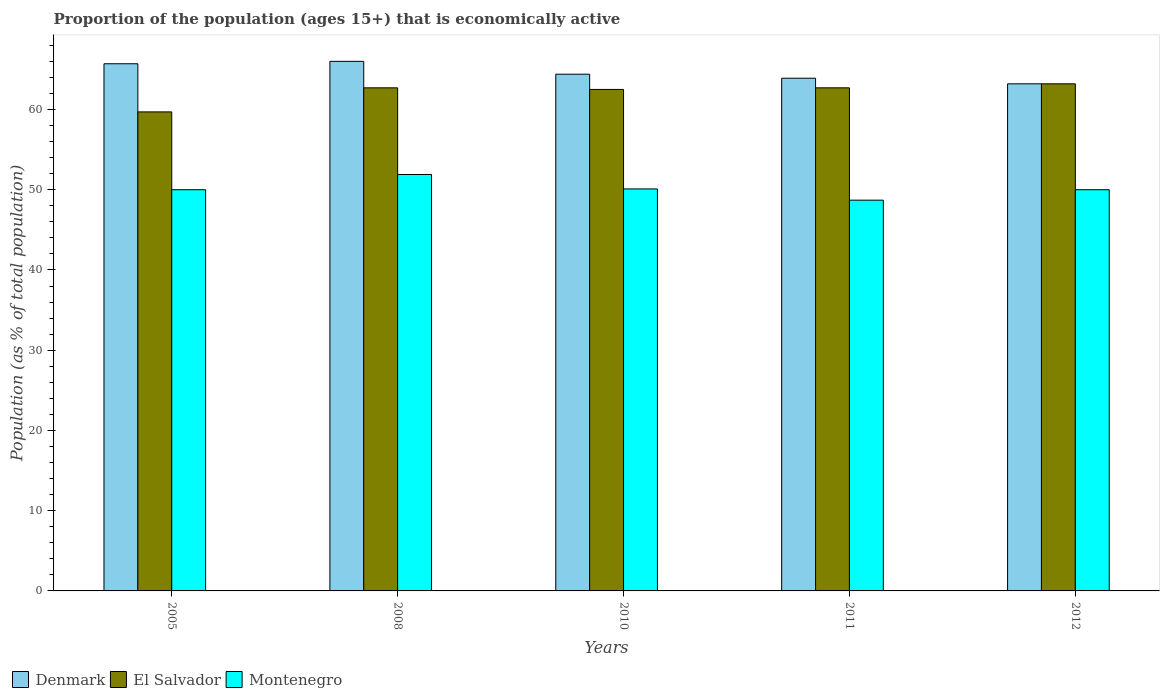Are the number of bars on each tick of the X-axis equal?
Your answer should be compact. Yes. In how many cases, is the number of bars for a given year not equal to the number of legend labels?
Give a very brief answer. 0. Across all years, what is the maximum proportion of the population that is economically active in Montenegro?
Provide a short and direct response. 51.9. Across all years, what is the minimum proportion of the population that is economically active in El Salvador?
Keep it short and to the point. 59.7. In which year was the proportion of the population that is economically active in El Salvador maximum?
Provide a short and direct response. 2012. In which year was the proportion of the population that is economically active in Montenegro minimum?
Your answer should be compact. 2011. What is the total proportion of the population that is economically active in Montenegro in the graph?
Your answer should be very brief. 250.7. What is the difference between the proportion of the population that is economically active in Denmark in 2008 and that in 2011?
Give a very brief answer. 2.1. What is the difference between the proportion of the population that is economically active in Montenegro in 2005 and the proportion of the population that is economically active in Denmark in 2012?
Offer a terse response. -13.2. What is the average proportion of the population that is economically active in Montenegro per year?
Make the answer very short. 50.14. In the year 2011, what is the difference between the proportion of the population that is economically active in Denmark and proportion of the population that is economically active in Montenegro?
Your answer should be very brief. 15.2. In how many years, is the proportion of the population that is economically active in Montenegro greater than 2 %?
Offer a terse response. 5. What is the ratio of the proportion of the population that is economically active in El Salvador in 2008 to that in 2011?
Offer a very short reply. 1. What is the difference between the highest and the second highest proportion of the population that is economically active in Montenegro?
Provide a short and direct response. 1.8. What is the difference between the highest and the lowest proportion of the population that is economically active in Montenegro?
Provide a short and direct response. 3.2. Is the sum of the proportion of the population that is economically active in El Salvador in 2005 and 2008 greater than the maximum proportion of the population that is economically active in Denmark across all years?
Your response must be concise. Yes. What does the 2nd bar from the left in 2005 represents?
Provide a succinct answer. El Salvador. What does the 2nd bar from the right in 2010 represents?
Your answer should be very brief. El Salvador. Is it the case that in every year, the sum of the proportion of the population that is economically active in El Salvador and proportion of the population that is economically active in Montenegro is greater than the proportion of the population that is economically active in Denmark?
Ensure brevity in your answer.  Yes. How many bars are there?
Your response must be concise. 15. Are all the bars in the graph horizontal?
Provide a short and direct response. No. What is the difference between two consecutive major ticks on the Y-axis?
Your answer should be compact. 10. Does the graph contain any zero values?
Make the answer very short. No. Where does the legend appear in the graph?
Your response must be concise. Bottom left. How many legend labels are there?
Provide a succinct answer. 3. How are the legend labels stacked?
Keep it short and to the point. Horizontal. What is the title of the graph?
Your answer should be very brief. Proportion of the population (ages 15+) that is economically active. Does "Pacific island small states" appear as one of the legend labels in the graph?
Provide a short and direct response. No. What is the label or title of the Y-axis?
Your answer should be compact. Population (as % of total population). What is the Population (as % of total population) in Denmark in 2005?
Keep it short and to the point. 65.7. What is the Population (as % of total population) of El Salvador in 2005?
Keep it short and to the point. 59.7. What is the Population (as % of total population) in Montenegro in 2005?
Offer a terse response. 50. What is the Population (as % of total population) of Denmark in 2008?
Ensure brevity in your answer.  66. What is the Population (as % of total population) of El Salvador in 2008?
Your answer should be very brief. 62.7. What is the Population (as % of total population) of Montenegro in 2008?
Your answer should be very brief. 51.9. What is the Population (as % of total population) of Denmark in 2010?
Keep it short and to the point. 64.4. What is the Population (as % of total population) of El Salvador in 2010?
Give a very brief answer. 62.5. What is the Population (as % of total population) in Montenegro in 2010?
Provide a succinct answer. 50.1. What is the Population (as % of total population) in Denmark in 2011?
Give a very brief answer. 63.9. What is the Population (as % of total population) in El Salvador in 2011?
Offer a terse response. 62.7. What is the Population (as % of total population) in Montenegro in 2011?
Make the answer very short. 48.7. What is the Population (as % of total population) in Denmark in 2012?
Give a very brief answer. 63.2. What is the Population (as % of total population) in El Salvador in 2012?
Keep it short and to the point. 63.2. Across all years, what is the maximum Population (as % of total population) of Denmark?
Provide a succinct answer. 66. Across all years, what is the maximum Population (as % of total population) of El Salvador?
Keep it short and to the point. 63.2. Across all years, what is the maximum Population (as % of total population) in Montenegro?
Offer a very short reply. 51.9. Across all years, what is the minimum Population (as % of total population) of Denmark?
Give a very brief answer. 63.2. Across all years, what is the minimum Population (as % of total population) of El Salvador?
Keep it short and to the point. 59.7. Across all years, what is the minimum Population (as % of total population) of Montenegro?
Give a very brief answer. 48.7. What is the total Population (as % of total population) of Denmark in the graph?
Provide a short and direct response. 323.2. What is the total Population (as % of total population) in El Salvador in the graph?
Your response must be concise. 310.8. What is the total Population (as % of total population) of Montenegro in the graph?
Offer a terse response. 250.7. What is the difference between the Population (as % of total population) in Denmark in 2005 and that in 2008?
Your answer should be very brief. -0.3. What is the difference between the Population (as % of total population) in El Salvador in 2005 and that in 2008?
Offer a very short reply. -3. What is the difference between the Population (as % of total population) in Montenegro in 2005 and that in 2008?
Give a very brief answer. -1.9. What is the difference between the Population (as % of total population) in Denmark in 2005 and that in 2010?
Offer a very short reply. 1.3. What is the difference between the Population (as % of total population) in Montenegro in 2005 and that in 2010?
Your answer should be very brief. -0.1. What is the difference between the Population (as % of total population) of Montenegro in 2005 and that in 2012?
Make the answer very short. 0. What is the difference between the Population (as % of total population) in Montenegro in 2008 and that in 2010?
Your answer should be compact. 1.8. What is the difference between the Population (as % of total population) in Montenegro in 2008 and that in 2011?
Provide a succinct answer. 3.2. What is the difference between the Population (as % of total population) in Montenegro in 2008 and that in 2012?
Ensure brevity in your answer.  1.9. What is the difference between the Population (as % of total population) of Montenegro in 2010 and that in 2011?
Make the answer very short. 1.4. What is the difference between the Population (as % of total population) of Denmark in 2010 and that in 2012?
Your response must be concise. 1.2. What is the difference between the Population (as % of total population) in El Salvador in 2010 and that in 2012?
Ensure brevity in your answer.  -0.7. What is the difference between the Population (as % of total population) in Montenegro in 2010 and that in 2012?
Your answer should be compact. 0.1. What is the difference between the Population (as % of total population) of El Salvador in 2011 and that in 2012?
Provide a succinct answer. -0.5. What is the difference between the Population (as % of total population) of Denmark in 2005 and the Population (as % of total population) of El Salvador in 2008?
Make the answer very short. 3. What is the difference between the Population (as % of total population) of El Salvador in 2005 and the Population (as % of total population) of Montenegro in 2008?
Ensure brevity in your answer.  7.8. What is the difference between the Population (as % of total population) of Denmark in 2005 and the Population (as % of total population) of El Salvador in 2011?
Keep it short and to the point. 3. What is the difference between the Population (as % of total population) of Denmark in 2005 and the Population (as % of total population) of Montenegro in 2011?
Your answer should be compact. 17. What is the difference between the Population (as % of total population) in Denmark in 2005 and the Population (as % of total population) in El Salvador in 2012?
Keep it short and to the point. 2.5. What is the difference between the Population (as % of total population) of Denmark in 2005 and the Population (as % of total population) of Montenegro in 2012?
Offer a very short reply. 15.7. What is the difference between the Population (as % of total population) of Denmark in 2008 and the Population (as % of total population) of El Salvador in 2010?
Provide a succinct answer. 3.5. What is the difference between the Population (as % of total population) of El Salvador in 2008 and the Population (as % of total population) of Montenegro in 2010?
Provide a succinct answer. 12.6. What is the difference between the Population (as % of total population) in Denmark in 2008 and the Population (as % of total population) in Montenegro in 2011?
Your answer should be very brief. 17.3. What is the difference between the Population (as % of total population) in Denmark in 2008 and the Population (as % of total population) in El Salvador in 2012?
Your answer should be very brief. 2.8. What is the difference between the Population (as % of total population) in El Salvador in 2008 and the Population (as % of total population) in Montenegro in 2012?
Provide a succinct answer. 12.7. What is the difference between the Population (as % of total population) in Denmark in 2010 and the Population (as % of total population) in Montenegro in 2011?
Provide a succinct answer. 15.7. What is the difference between the Population (as % of total population) of El Salvador in 2010 and the Population (as % of total population) of Montenegro in 2011?
Your answer should be very brief. 13.8. What is the difference between the Population (as % of total population) of Denmark in 2010 and the Population (as % of total population) of Montenegro in 2012?
Your answer should be very brief. 14.4. What is the difference between the Population (as % of total population) of Denmark in 2011 and the Population (as % of total population) of Montenegro in 2012?
Your answer should be very brief. 13.9. What is the difference between the Population (as % of total population) of El Salvador in 2011 and the Population (as % of total population) of Montenegro in 2012?
Your answer should be compact. 12.7. What is the average Population (as % of total population) of Denmark per year?
Ensure brevity in your answer.  64.64. What is the average Population (as % of total population) in El Salvador per year?
Provide a succinct answer. 62.16. What is the average Population (as % of total population) in Montenegro per year?
Your answer should be compact. 50.14. In the year 2008, what is the difference between the Population (as % of total population) in El Salvador and Population (as % of total population) in Montenegro?
Keep it short and to the point. 10.8. In the year 2010, what is the difference between the Population (as % of total population) in Denmark and Population (as % of total population) in Montenegro?
Your response must be concise. 14.3. In the year 2010, what is the difference between the Population (as % of total population) of El Salvador and Population (as % of total population) of Montenegro?
Your response must be concise. 12.4. In the year 2011, what is the difference between the Population (as % of total population) of Denmark and Population (as % of total population) of El Salvador?
Your response must be concise. 1.2. In the year 2012, what is the difference between the Population (as % of total population) of Denmark and Population (as % of total population) of El Salvador?
Your response must be concise. 0. In the year 2012, what is the difference between the Population (as % of total population) in El Salvador and Population (as % of total population) in Montenegro?
Your answer should be very brief. 13.2. What is the ratio of the Population (as % of total population) of Denmark in 2005 to that in 2008?
Give a very brief answer. 1. What is the ratio of the Population (as % of total population) of El Salvador in 2005 to that in 2008?
Your response must be concise. 0.95. What is the ratio of the Population (as % of total population) in Montenegro in 2005 to that in 2008?
Your response must be concise. 0.96. What is the ratio of the Population (as % of total population) in Denmark in 2005 to that in 2010?
Give a very brief answer. 1.02. What is the ratio of the Population (as % of total population) of El Salvador in 2005 to that in 2010?
Your answer should be very brief. 0.96. What is the ratio of the Population (as % of total population) in Denmark in 2005 to that in 2011?
Make the answer very short. 1.03. What is the ratio of the Population (as % of total population) in El Salvador in 2005 to that in 2011?
Offer a very short reply. 0.95. What is the ratio of the Population (as % of total population) of Montenegro in 2005 to that in 2011?
Keep it short and to the point. 1.03. What is the ratio of the Population (as % of total population) of Denmark in 2005 to that in 2012?
Provide a short and direct response. 1.04. What is the ratio of the Population (as % of total population) in El Salvador in 2005 to that in 2012?
Your answer should be compact. 0.94. What is the ratio of the Population (as % of total population) in Montenegro in 2005 to that in 2012?
Make the answer very short. 1. What is the ratio of the Population (as % of total population) in Denmark in 2008 to that in 2010?
Your answer should be very brief. 1.02. What is the ratio of the Population (as % of total population) in El Salvador in 2008 to that in 2010?
Make the answer very short. 1. What is the ratio of the Population (as % of total population) of Montenegro in 2008 to that in 2010?
Keep it short and to the point. 1.04. What is the ratio of the Population (as % of total population) of Denmark in 2008 to that in 2011?
Ensure brevity in your answer.  1.03. What is the ratio of the Population (as % of total population) in El Salvador in 2008 to that in 2011?
Your answer should be very brief. 1. What is the ratio of the Population (as % of total population) in Montenegro in 2008 to that in 2011?
Ensure brevity in your answer.  1.07. What is the ratio of the Population (as % of total population) of Denmark in 2008 to that in 2012?
Your response must be concise. 1.04. What is the ratio of the Population (as % of total population) in Montenegro in 2008 to that in 2012?
Give a very brief answer. 1.04. What is the ratio of the Population (as % of total population) in Denmark in 2010 to that in 2011?
Your response must be concise. 1.01. What is the ratio of the Population (as % of total population) of El Salvador in 2010 to that in 2011?
Your response must be concise. 1. What is the ratio of the Population (as % of total population) of Montenegro in 2010 to that in 2011?
Ensure brevity in your answer.  1.03. What is the ratio of the Population (as % of total population) in Denmark in 2010 to that in 2012?
Ensure brevity in your answer.  1.02. What is the ratio of the Population (as % of total population) of El Salvador in 2010 to that in 2012?
Give a very brief answer. 0.99. What is the ratio of the Population (as % of total population) in Denmark in 2011 to that in 2012?
Keep it short and to the point. 1.01. What is the difference between the highest and the second highest Population (as % of total population) of Montenegro?
Offer a very short reply. 1.8. What is the difference between the highest and the lowest Population (as % of total population) in Denmark?
Your response must be concise. 2.8. What is the difference between the highest and the lowest Population (as % of total population) of Montenegro?
Offer a very short reply. 3.2. 